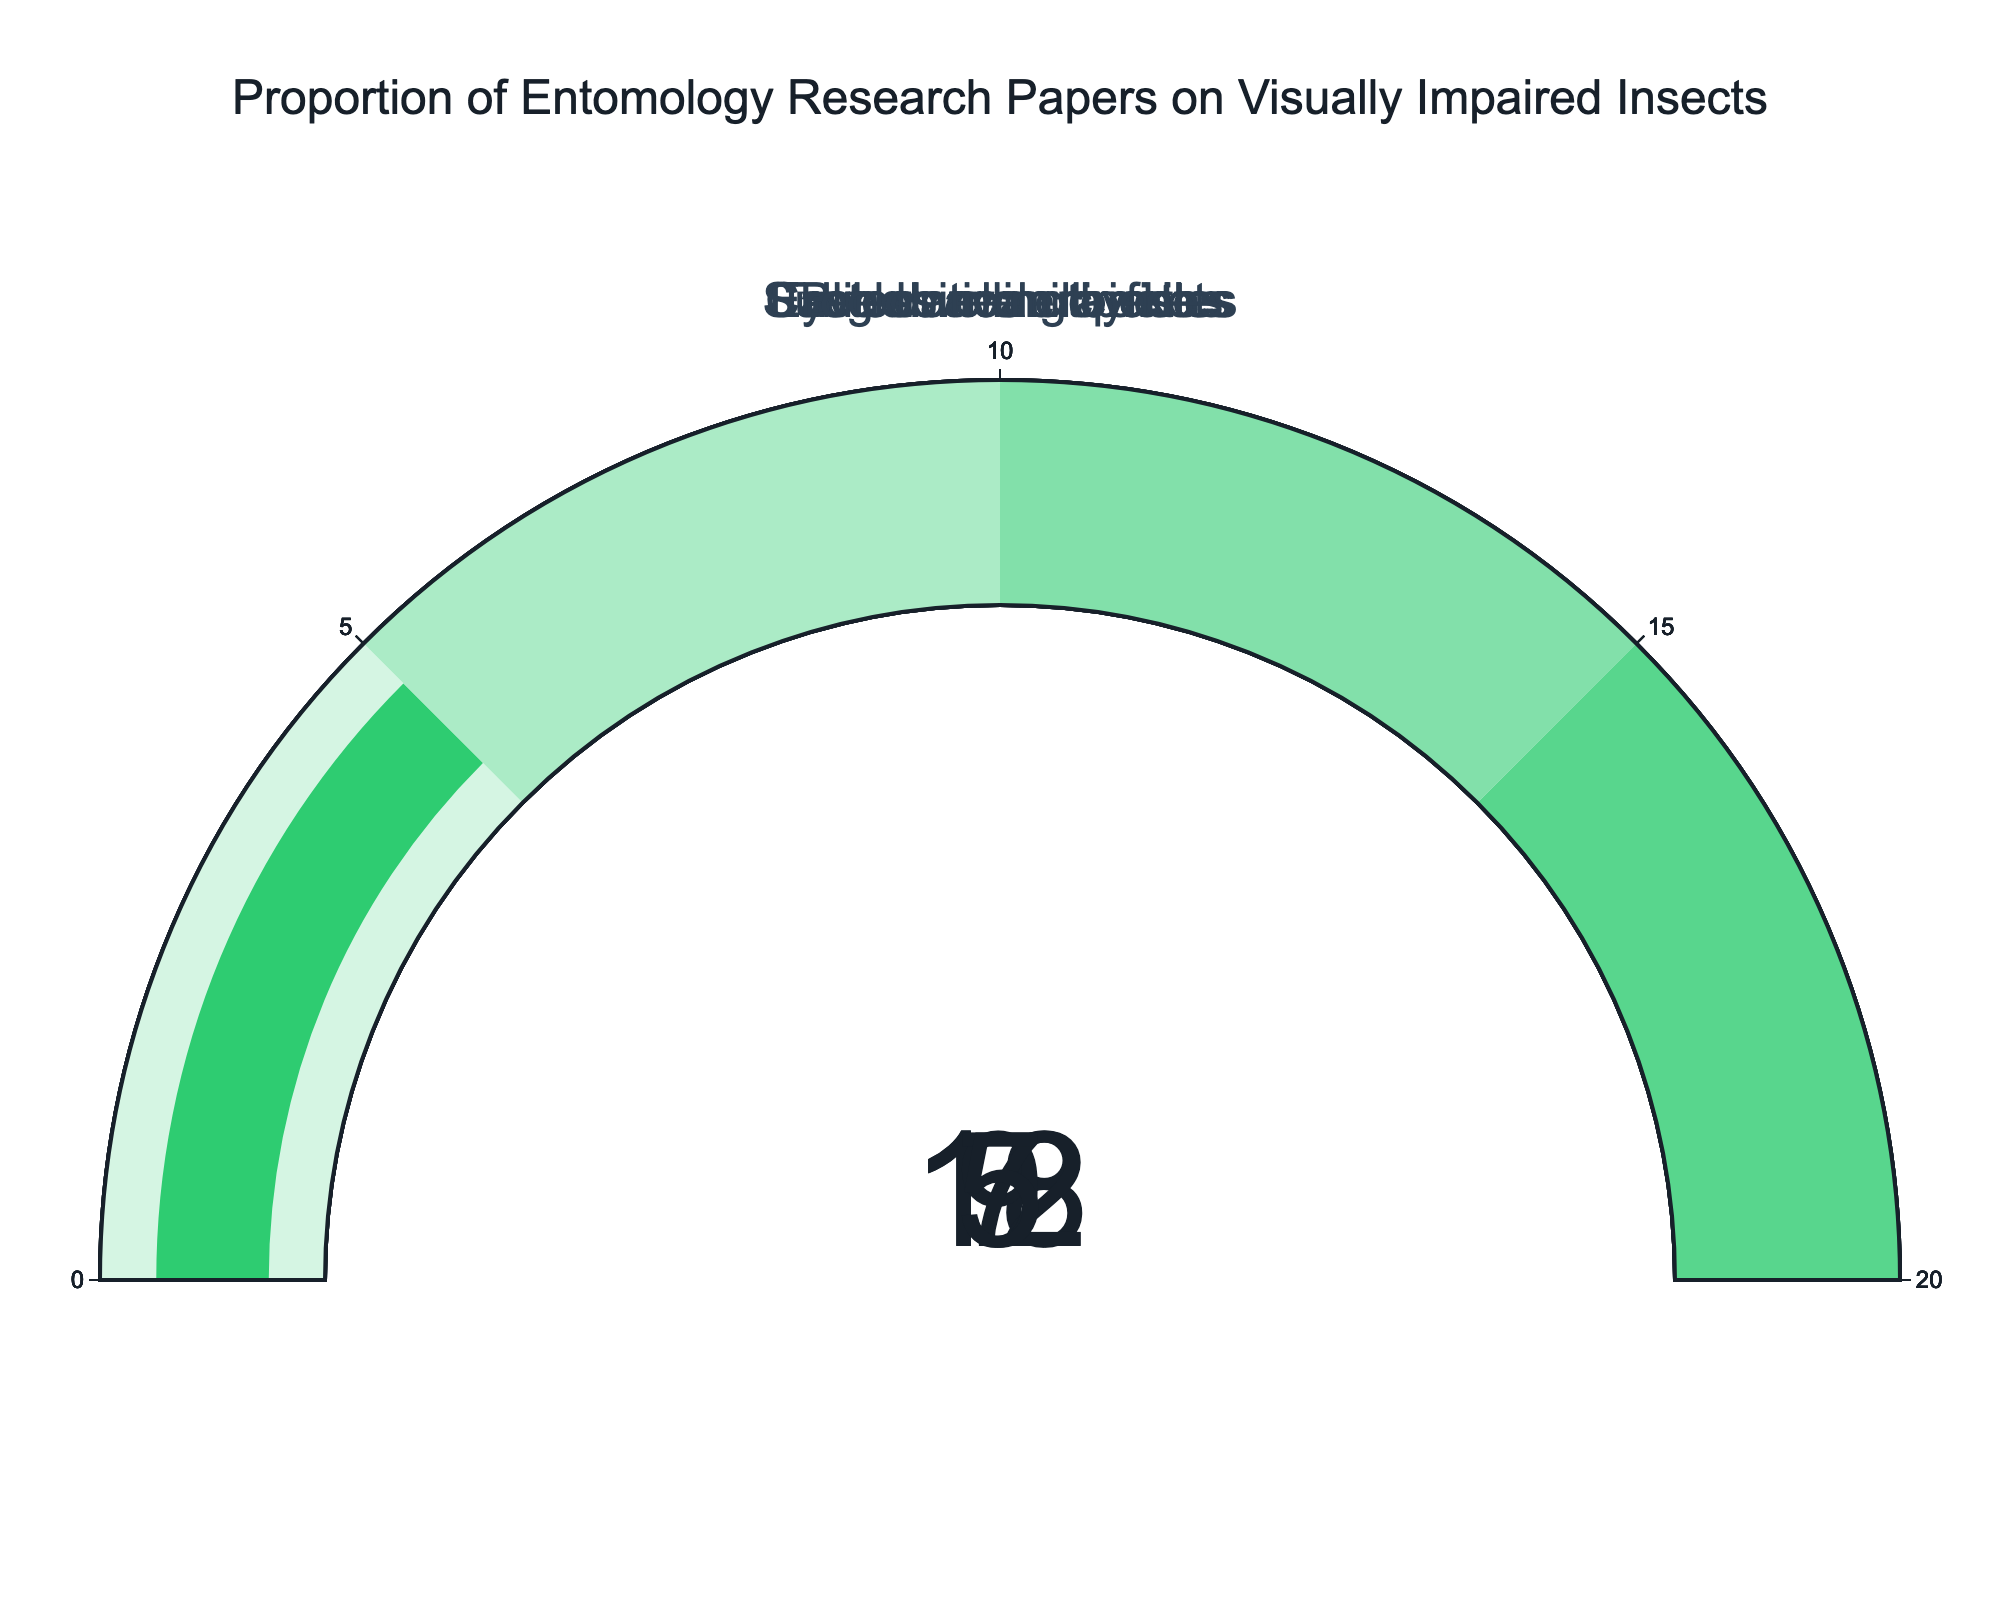What is the title of the figure? The title of the figure is displayed at the top and summarizes the content of the figure. Reading the title allows you to understand the general topic being visualized.
Answer: Proportion of Entomology Research Papers on Visually Impaired Insects What is the proportion of research papers focusing on cave-dwelling beetles? The gauge chart corresponding to cave-dwelling beetles shows the proportion as a number inside the gauge.
Answer: 18% Which category has the lowest proportion of research papers? To find this, read the value displayed on each gauge and identify the smallest number.
Answer: Troglobitic millipedes What is the combined proportion of studies focused on subterranean termites and blind cave crayfish? Add the percentages for subterranean termites and blind cave crayfish. The values are 9% and 7% respectively. So, 9 + 7 = 16.
Answer: 16% Which two categories combined have a proportion equal to or greater than cave-dwelling beetles? Cave-dwelling beetles have a proportion of 18%. By looking at other categories, subterranean termites (9%) and eyeless mole crickets (12%) provide 9 + 12 = 21, which is greater than 18. Blind cave crayfish (7%) and eyeless mole crickets (12%) give 7 + 12 = 19, also greater than 18.
Answer: Subterranean termites + Eyeless mole crickets, or Blind cave crayfish + Eyeless mole crickets How many categories have a proportion of 10% or higher? Count the number of gauges showing percentages 10% or above. Cave-dwelling beetles (18%) and eyeless mole crickets (12%) are above 10%.
Answer: 2 Which category has a proportion closest to 10%? Check the percentages displayed on the gauges and find the one nearest to 10%. Subterranean termites are at 9%, which is the closest to 10%.
Answer: Subterranean termites Is the proportion for troglobitic millipedes higher or lower than that for eyeless mole crickets? Compare the percentages of the two categories. Troglobitic millipedes are at 5%, while eyeless mole crickets are at 12%.
Answer: Lower If the total number of research papers is 1000, how many papers focus on eyeless mole crickets? To find the number of papers, use the percentage provided. For eyeless mole crickets, which is 12%, calculate 12% of 1000. 0.12 * 1000 = 120.
Answer: 120 